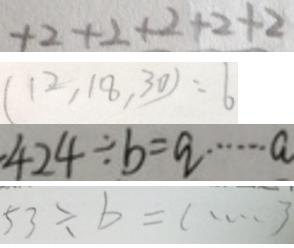<formula> <loc_0><loc_0><loc_500><loc_500>+ 2 + 2 + 2 + 2 + 2 
 ( 1 2 , 1 8 , 3 0 ) = 6 
 4 2 4 \div b = q \cdots a 
 5 3 \div b = l \cdots 3</formula> 